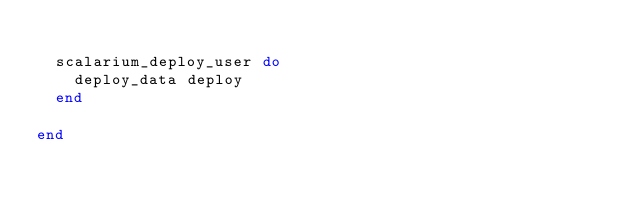<code> <loc_0><loc_0><loc_500><loc_500><_Ruby_>
  scalarium_deploy_user do
    deploy_data deploy
  end

end</code> 